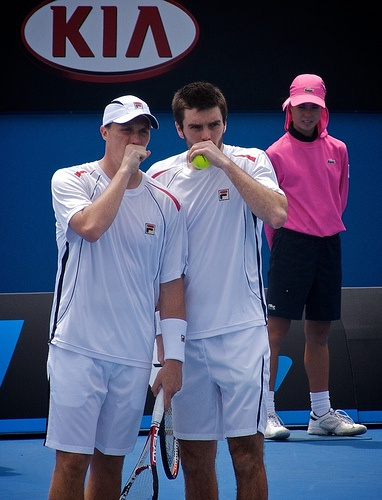Describe the objects in this image and their specific colors. I can see people in black, darkgray, and gray tones, people in black, darkgray, and gray tones, people in black, purple, and maroon tones, tennis racket in black, gray, and darkgray tones, and tennis racket in black and gray tones in this image. 